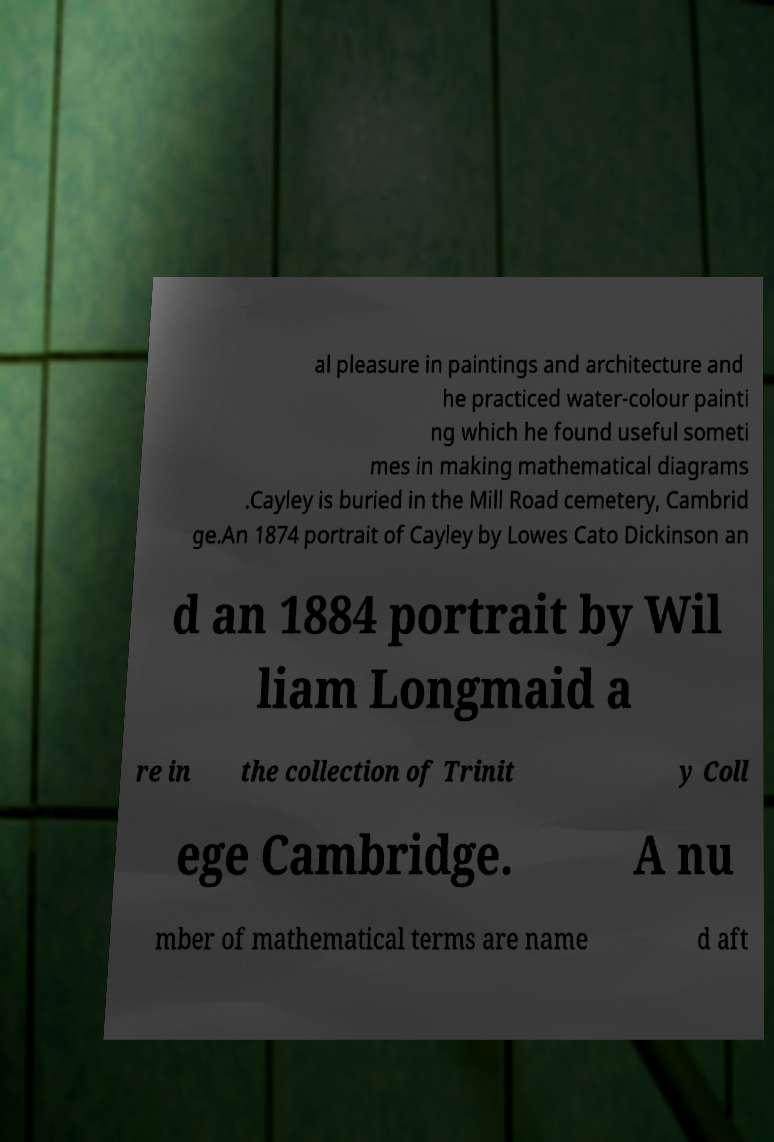There's text embedded in this image that I need extracted. Can you transcribe it verbatim? al pleasure in paintings and architecture and he practiced water-colour painti ng which he found useful someti mes in making mathematical diagrams .Cayley is buried in the Mill Road cemetery, Cambrid ge.An 1874 portrait of Cayley by Lowes Cato Dickinson an d an 1884 portrait by Wil liam Longmaid a re in the collection of Trinit y Coll ege Cambridge. A nu mber of mathematical terms are name d aft 